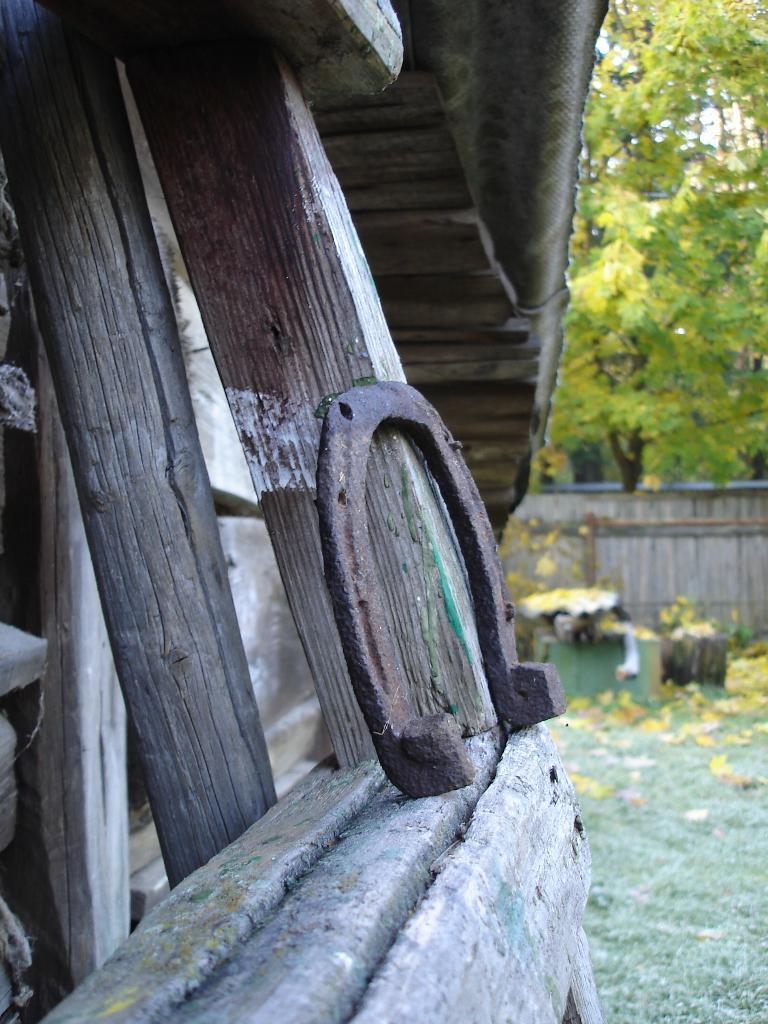What type of vegetation can be seen in the image? There are trees in the image. What is separating the trees from another area in the image? There is a fence in the image. What can be found on the ground in the image? There are objects on the ground in the image. What material are some of the poles made of in the image? There are wooden poles in the image. What type of material is the metal object made of in the image? There is a metal object in the image. What type of humor is being displayed by the mask in the image? There is no mask present in the image, so it is not possible to determine the type of humor being displayed. 